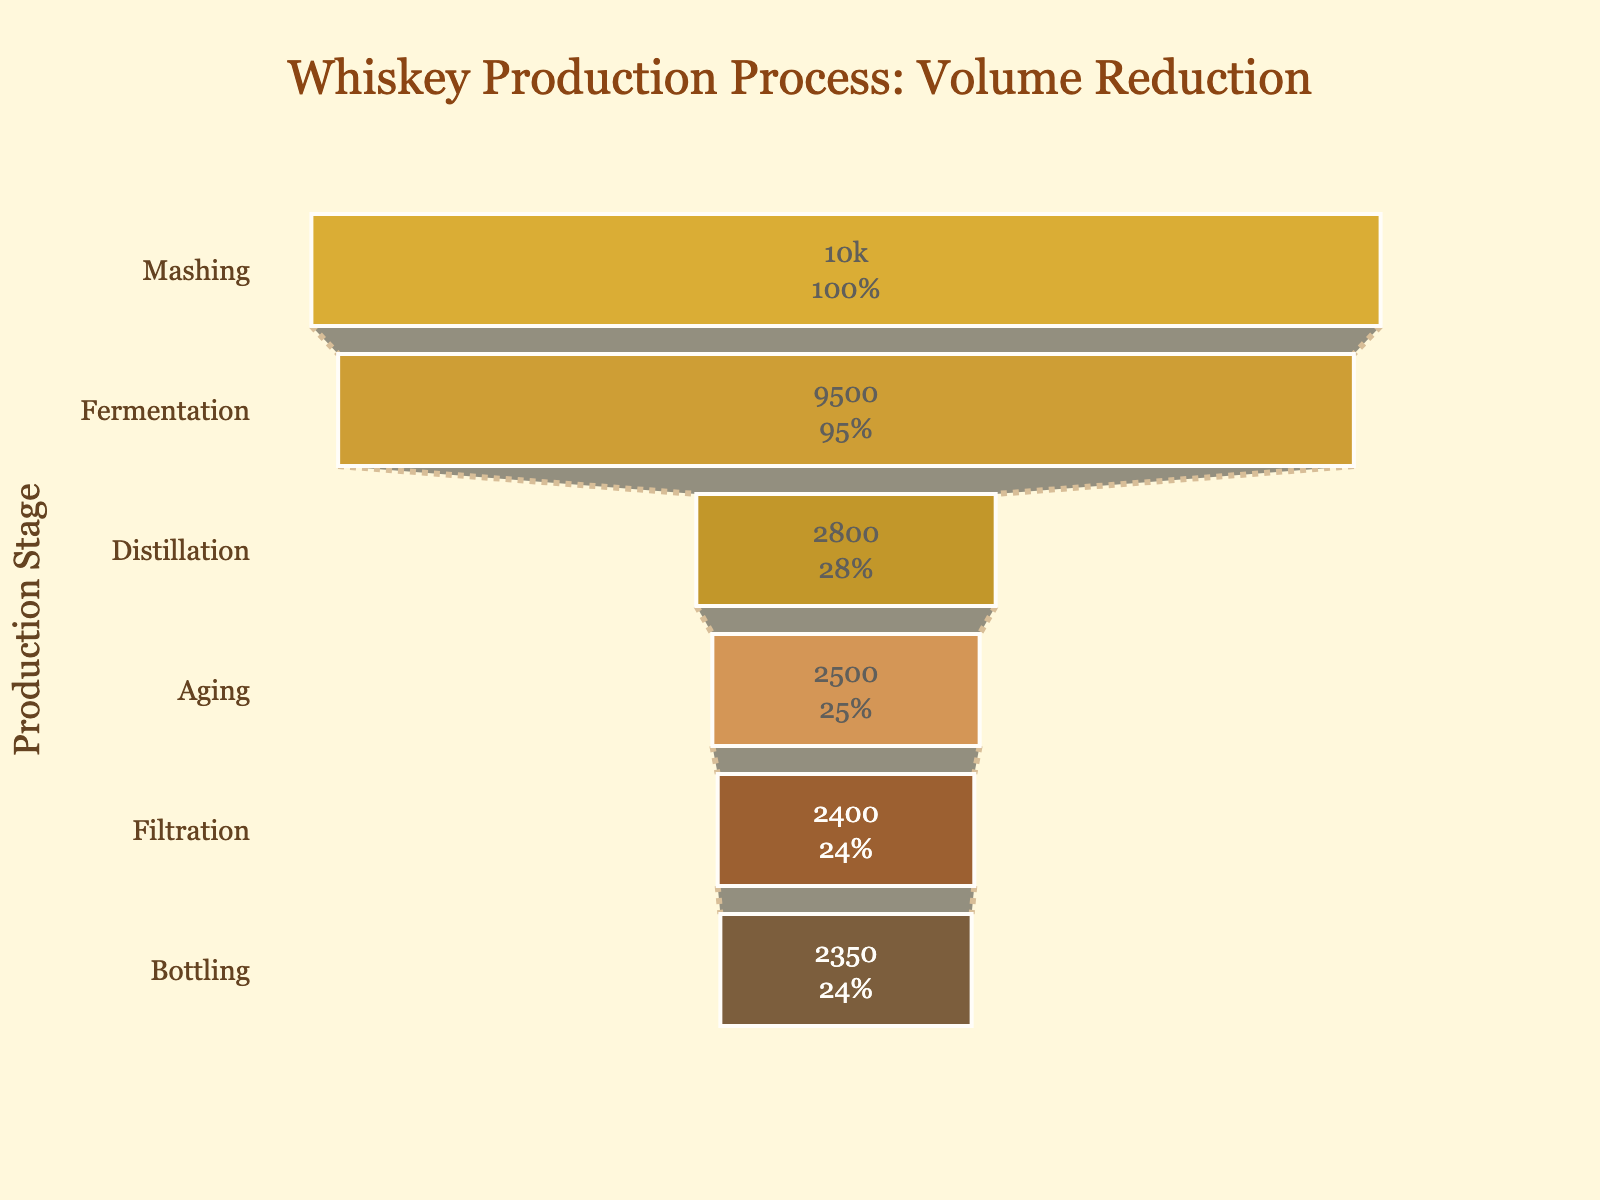What's the title of the figure? The title is located at the top center of the figure and reads, "Whiskey Production Process: Volume Reduction".
Answer: Whiskey Production Process: Volume Reduction How many production stages are shown in the figure? Each stage corresponds to a distinct section in the funnel chart. Counting these sections from top to bottom, there are six stages.
Answer: Six What is the volume reduction between the Distillation and Aging stages? The volume at the Distillation stage is 2800 liters, and at the Aging stage, it is 2500 liters. Subtract 2500 from 2800 to get the reduction: 2800 - 2500 = 300 liters.
Answer: 300 liters Which stage shows the largest volume reduction compared to the previous stage? By comparing the volume reductions at each stage, we find the drop from Fermentation (9500 liters) to Distillation (2800 liters) is the largest. The reduction is 9500 - 2800 = 6700 liters.
Answer: Fermentation to Distillation What's the percentage of volume retained after the Bottling stage relative to the initial volume at the Mashing stage? The volume after Bottling is 2350 liters, and the initial volume at Mashing is 10000 liters. The retained percentage can be calculated as (2350 / 10000) * 100 = 23.5%.
Answer: 23.5% Which two successive stages have the smallest volume reduction? Comparing the differences between successive stages: Mashing to Fermentation (500 liters), Fermentation to Distillation (6700 liters), Distillation to Aging (300 liters), Aging to Filtration (100 liters), Filtration to Bottling (50 liters). The smallest reduction is from Filtration to Bottling.
Answer: Filtration to Bottling At which stage does the volume first fall below 5000 liters? Looking at the volume levels at each stage, the first time the volume falls below 5000 liters is at Distillation with a volume of 2800 liters.
Answer: Distillation By what percentage does the volume decrease from Mashing to Fermentation? The volume decreases from 10000 liters at Mashing to 9500 liters at Fermentation. The percentage decrease is ((10000 - 9500) / 10000) * 100 = 5%.
Answer: 5% What's the total volume reduction from the Mashing stage to the Bottling stage? The initial volume at Mashing is 10000 liters, and at Bottling it is 2350 liters. The total reduction is 10000 - 2350 = 7650 liters.
Answer: 7650 liters 